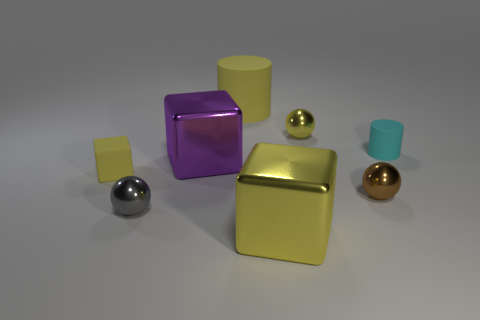How many shiny objects are big purple blocks or yellow balls?
Offer a terse response. 2. Is the tiny ball that is behind the cyan object made of the same material as the cylinder that is to the right of the big yellow cylinder?
Make the answer very short. No. What color is the tiny cylinder that is made of the same material as the large yellow cylinder?
Offer a terse response. Cyan. Are there more things in front of the large purple object than large yellow objects behind the tiny yellow matte cube?
Ensure brevity in your answer.  Yes. Are any large yellow metallic things visible?
Provide a short and direct response. Yes. What material is the small block that is the same color as the big cylinder?
Ensure brevity in your answer.  Rubber. How many things are small green metal objects or large metal blocks?
Your answer should be compact. 2. Are there any large cylinders of the same color as the matte cube?
Give a very brief answer. Yes. What number of tiny metal spheres are in front of the small matte thing that is right of the gray metal sphere?
Ensure brevity in your answer.  2. Are there more large purple cylinders than yellow blocks?
Provide a succinct answer. No. 